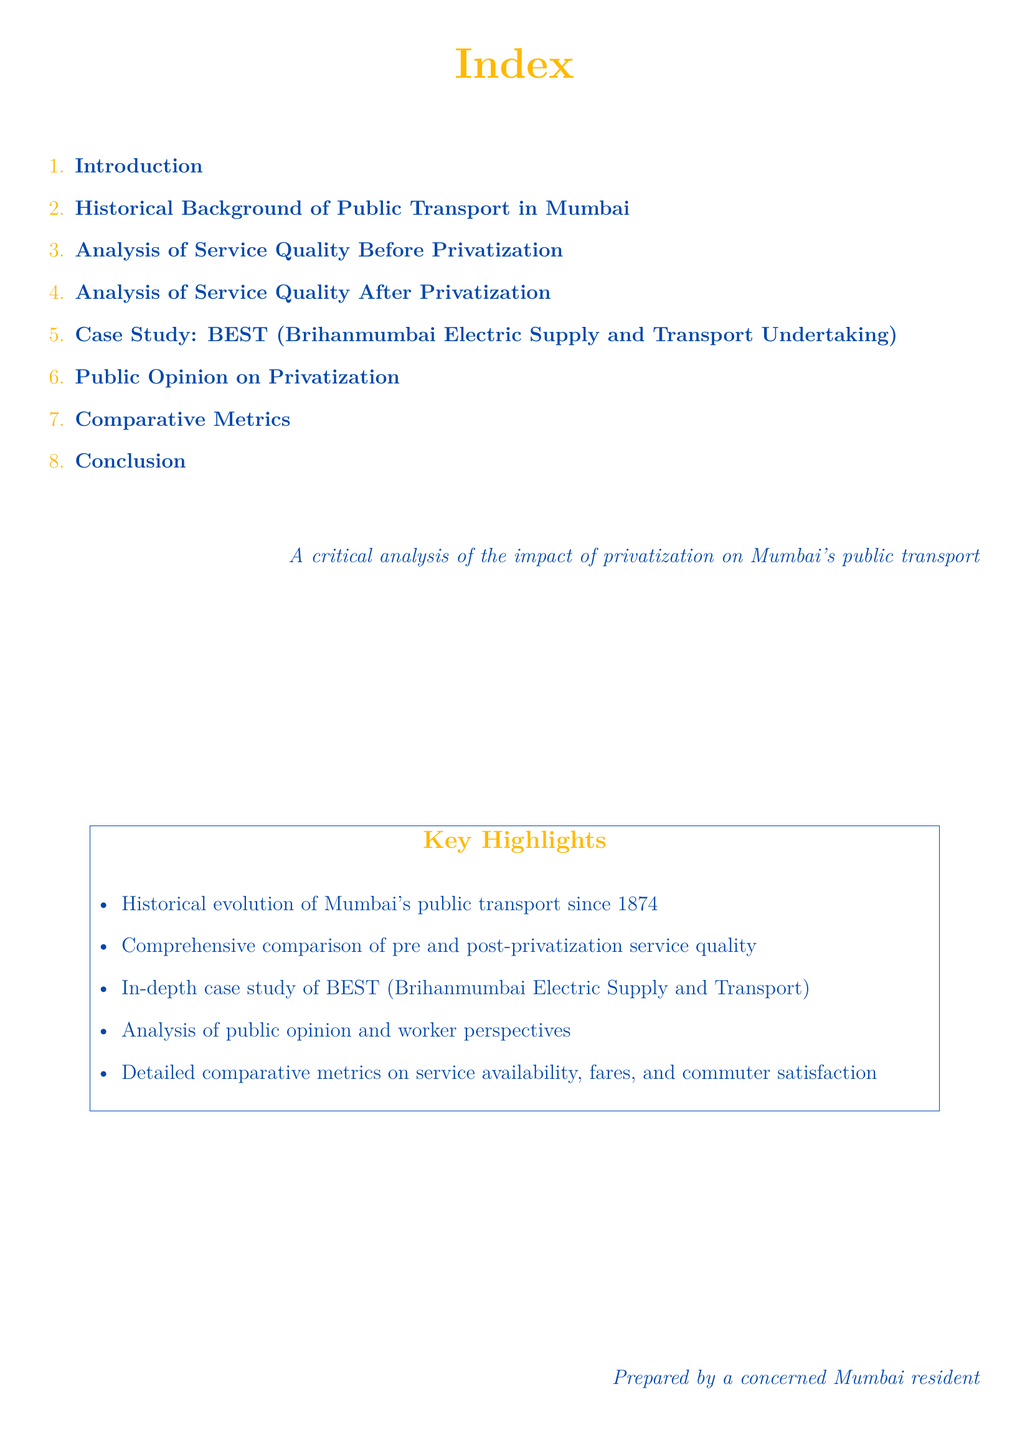What is the title of the document? The title of the document is highlighted in the center at the top of the page.
Answer: Index How many main sections are listed in the index? The index contains a list of eight main sections.
Answer: 8 What is the first section in the index? The first section of the index is the introductory part of the document.
Answer: Introduction What is the case study mentioned in the index? The index specifies the case study focused on a specific transport service in Mumbai.
Answer: BEST What color is used for the page background? The page background uses a distinct color that is associated with Mumbai.
Answer: white What year marks the historical evolution of public transport in Mumbai according to the key highlights? The key highlights mention that public transport in Mumbai began in a particular year.
Answer: 1874 What kind of analysis is performed on the service quality before and after privatization? The document features comparative analysis regarding the quality of services.
Answer: Comprehensive comparison Where does the document mention public opinion? Public opinion is addressed specifically in one of the sections of the index.
Answer: Public Opinion on Privatization Who prepared the document? The document attributes its preparation to a concerned resident of Mumbai.
Answer: A concerned Mumbai resident 